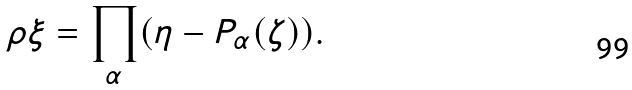<formula> <loc_0><loc_0><loc_500><loc_500>\rho \xi = \prod _ { \alpha } ( \eta - P _ { \alpha } ( \zeta ) ) .</formula> 